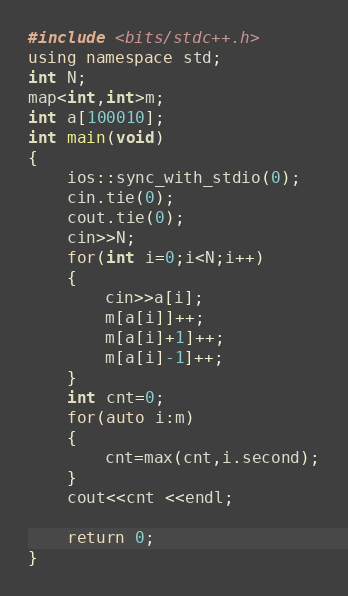<code> <loc_0><loc_0><loc_500><loc_500><_C++_>#include <bits/stdc++.h>
using namespace std;
int N;
map<int,int>m;
int a[100010];
int main(void)
{
    ios::sync_with_stdio(0);
    cin.tie(0);
    cout.tie(0);
    cin>>N;
    for(int i=0;i<N;i++)
    {
        cin>>a[i];
        m[a[i]]++;
        m[a[i]+1]++;
        m[a[i]-1]++;
    }
    int cnt=0;
    for(auto i:m)
    {
        cnt=max(cnt,i.second);
    }
    cout<<cnt <<endl;

    return 0;
}
</code> 